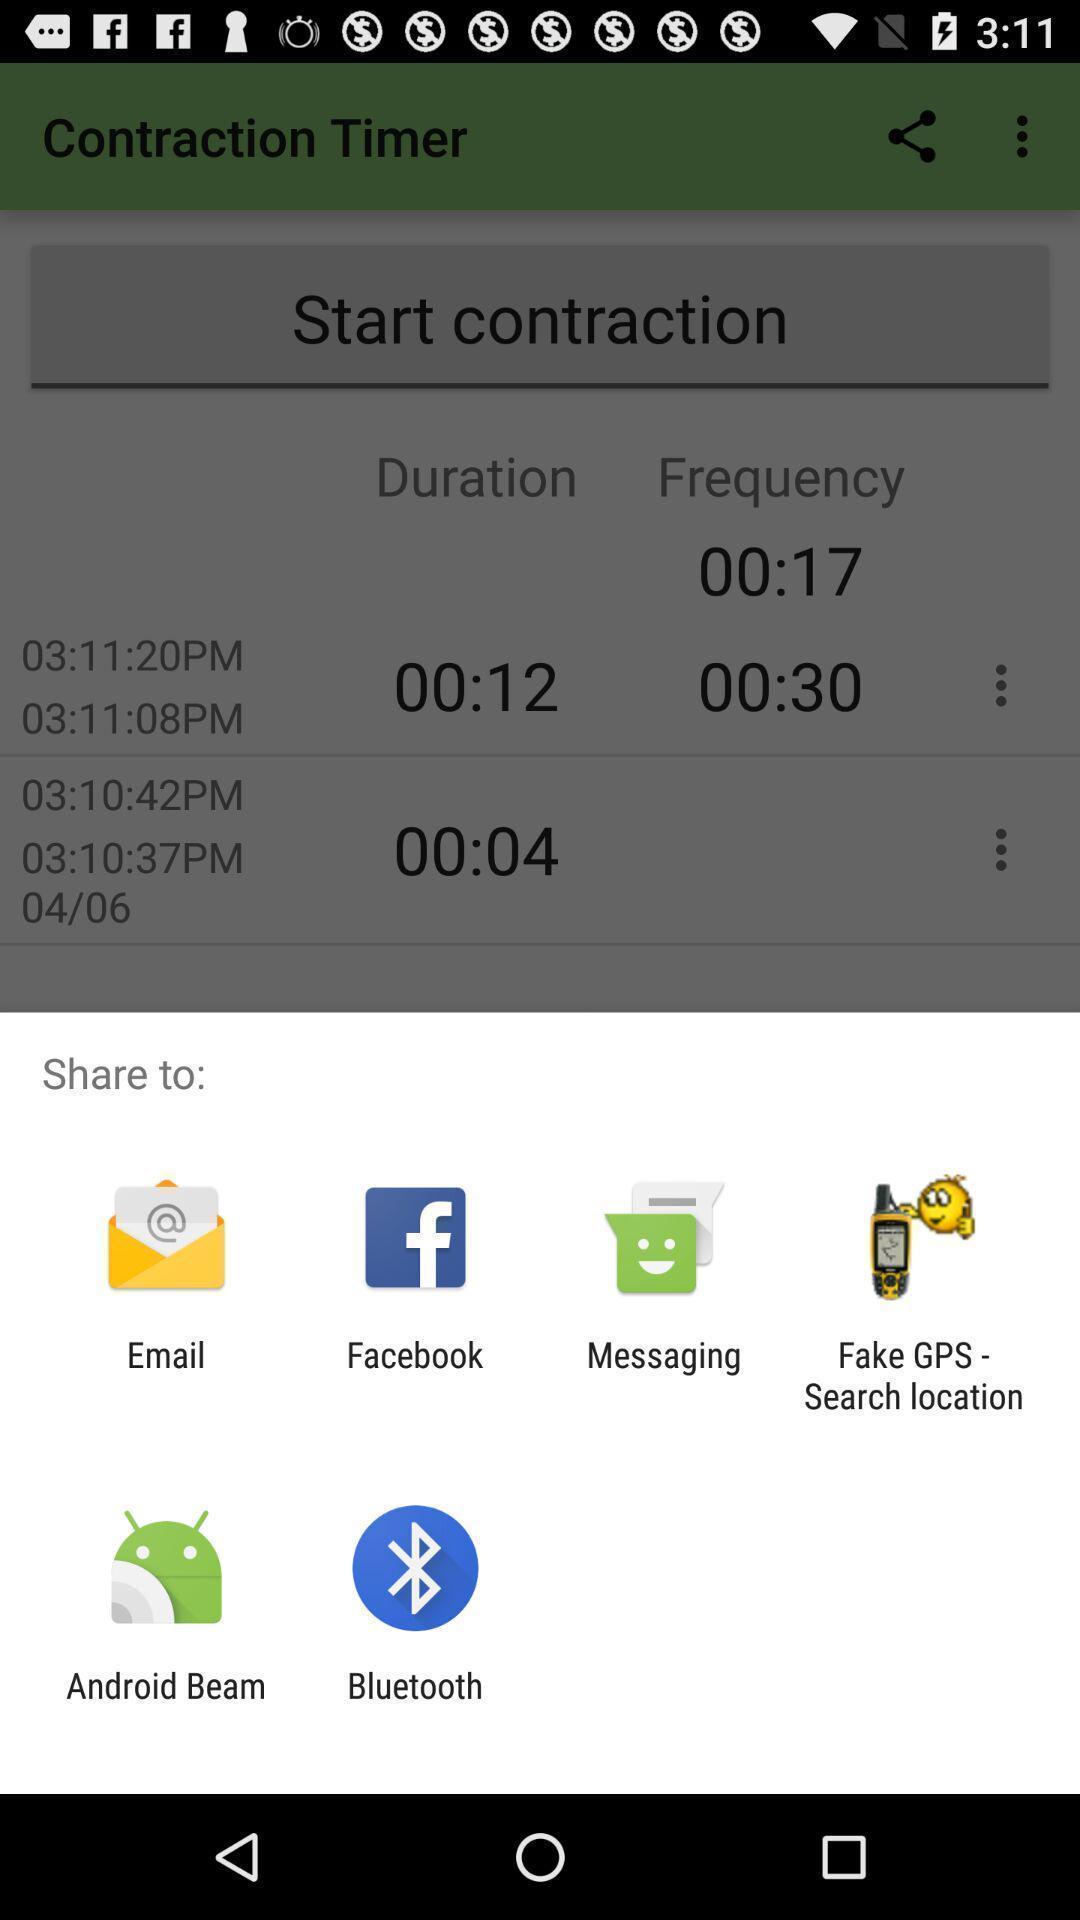Give me a narrative description of this picture. Push up message for sharing data via social network. 